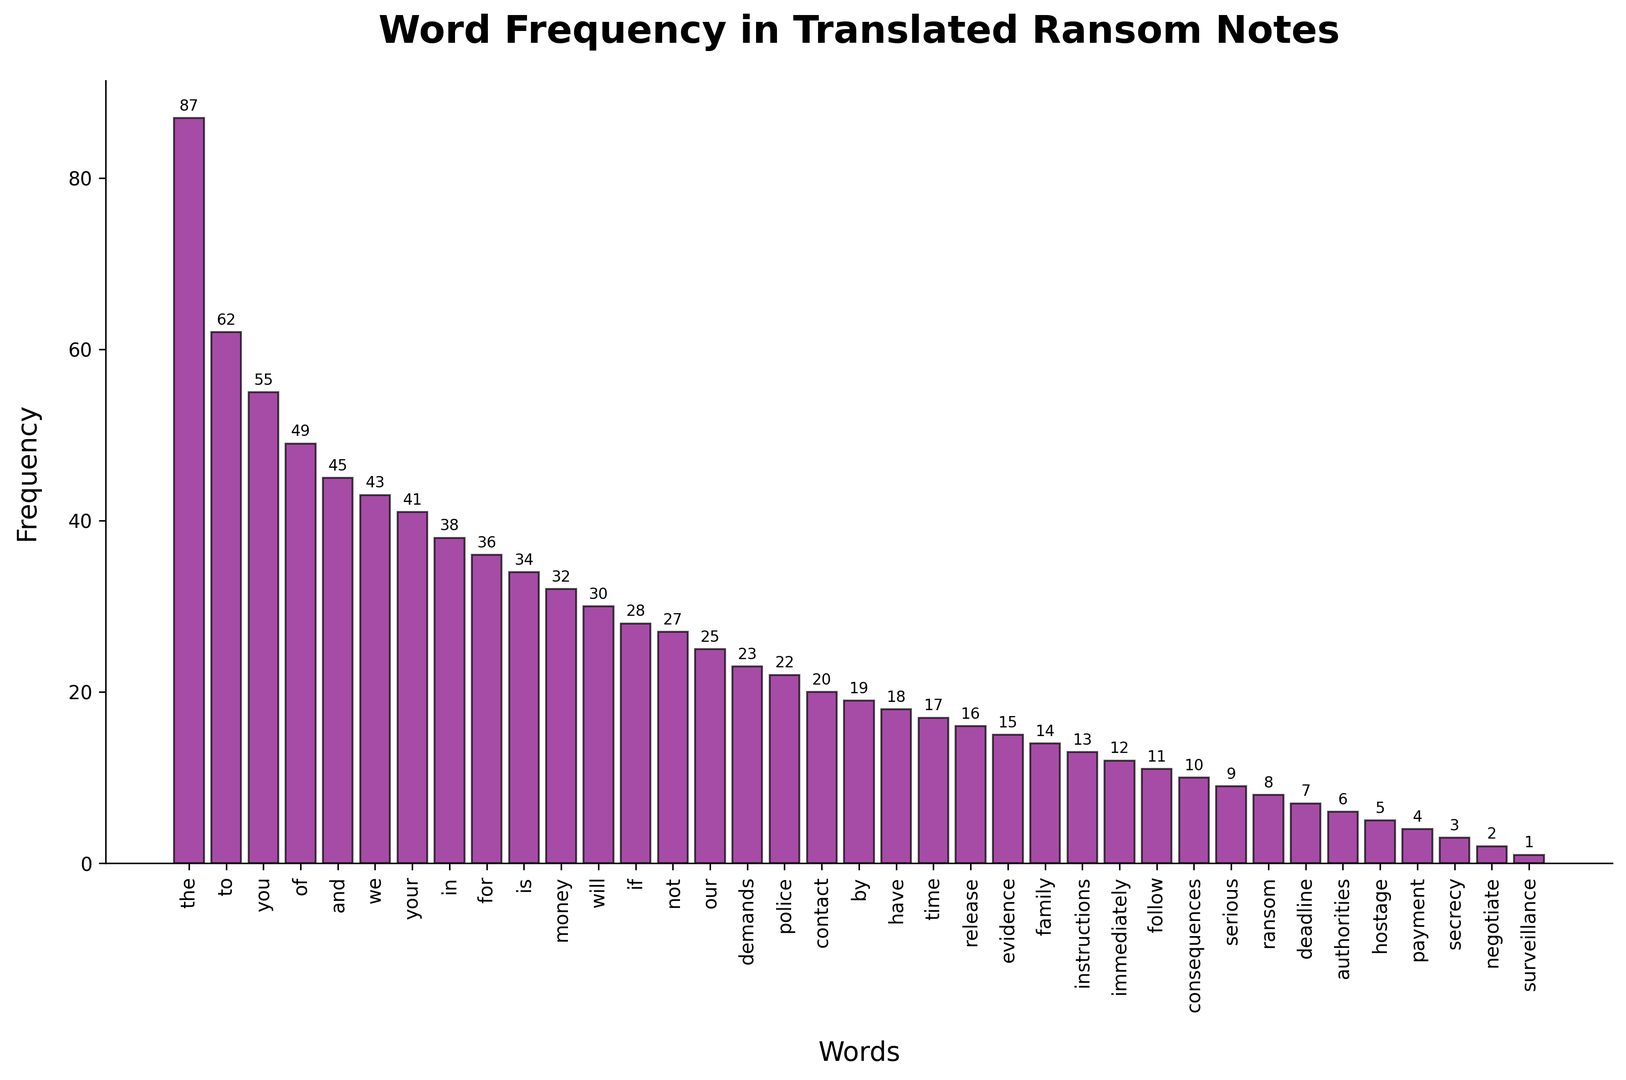What's the most frequently occurring word in the ransom notes? The tallest bar in the histogram represents the word with the highest frequency. From the figure, it is evident that "the" is the word with the tallest bar.
Answer: the Which word has a frequency of 34? Locate the bar that reaches a height of 34. The corresponding word at the base of this bar is "is".
Answer: is How many words have a frequency greater than 40? Count all the bars whose height exceeds 40. These words are: "the", "to", "you", "of", "and", "we", "your". There are 7 such words.
Answer: 7 Which words have a frequency between 30 and 40 inclusive? Identify bars whose heights fall in the range of 30 to 40. The words meeting this criterion are: "for", "is", "money", "will".
Answer: for, is, money, will What is the sum of the frequencies of "money" and "time"? From the histogram, the frequency of "money" is 32 and the frequency of "time" is 17. Adding these gives 32 + 17 = 49.
Answer: 49 Is the frequency of "contact" greater than "release"? Compare the heights of the bars for "contact" and "release". "Contact" has a frequency of 20, whereas "release" has a frequency of 16. Since 20 is greater than 16, "contact" has a higher frequency.
Answer: Yes Which word has the lowest frequency and what is it? The shortest bar in the histogram represents the word with the lowest frequency. This word is "surveillance" with a frequency of 1.
Answer: surveillance, 1 How does the frequency of "police" compare to "family"? Locate the bars for "police" and "family". The frequency for "police" is 22 and for "family" is 14. Since 22 is greater than 14, "police" has a higher frequency than "family".
Answer: police What is the difference in frequency between "demands" and "authorities"? From the plot, "demands" has a frequency of 23 and "authorities" has a frequency of 6. The difference is 23 - 6 = 17.
Answer: 17 What is the average frequency of the words "if", "not", and "our"? The frequencies of the words are "if" (28), "not" (27), and "our" (25). Calculating the average: (28 + 27 + 25) / 3 = 80 / 3 ≈ 26.67.
Answer: 26.67 